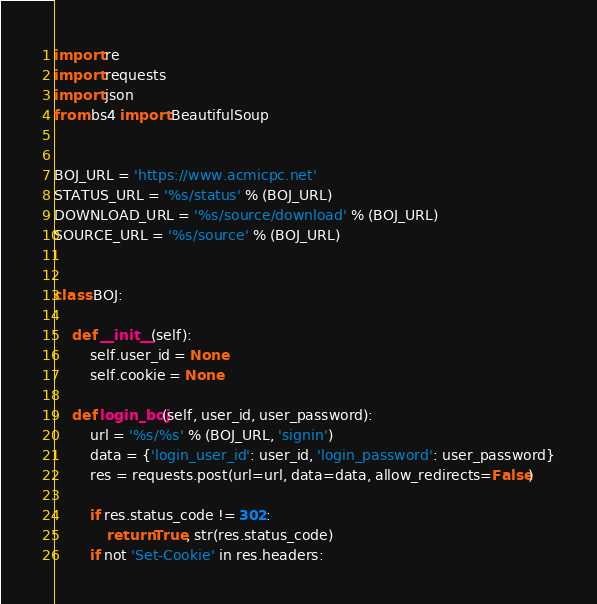<code> <loc_0><loc_0><loc_500><loc_500><_Python_>import re
import requests
import json
from bs4 import BeautifulSoup


BOJ_URL = 'https://www.acmicpc.net'
STATUS_URL = '%s/status' % (BOJ_URL)
DOWNLOAD_URL = '%s/source/download' % (BOJ_URL)
SOURCE_URL = '%s/source' % (BOJ_URL)


class BOJ:

    def __init__(self):
        self.user_id = None
        self.cookie = None

    def login_boj(self, user_id, user_password):
        url = '%s/%s' % (BOJ_URL, 'signin')
        data = {'login_user_id': user_id, 'login_password': user_password}
        res = requests.post(url=url, data=data, allow_redirects=False)

        if res.status_code != 302:
            return True, str(res.status_code)
        if not 'Set-Cookie' in res.headers:</code> 